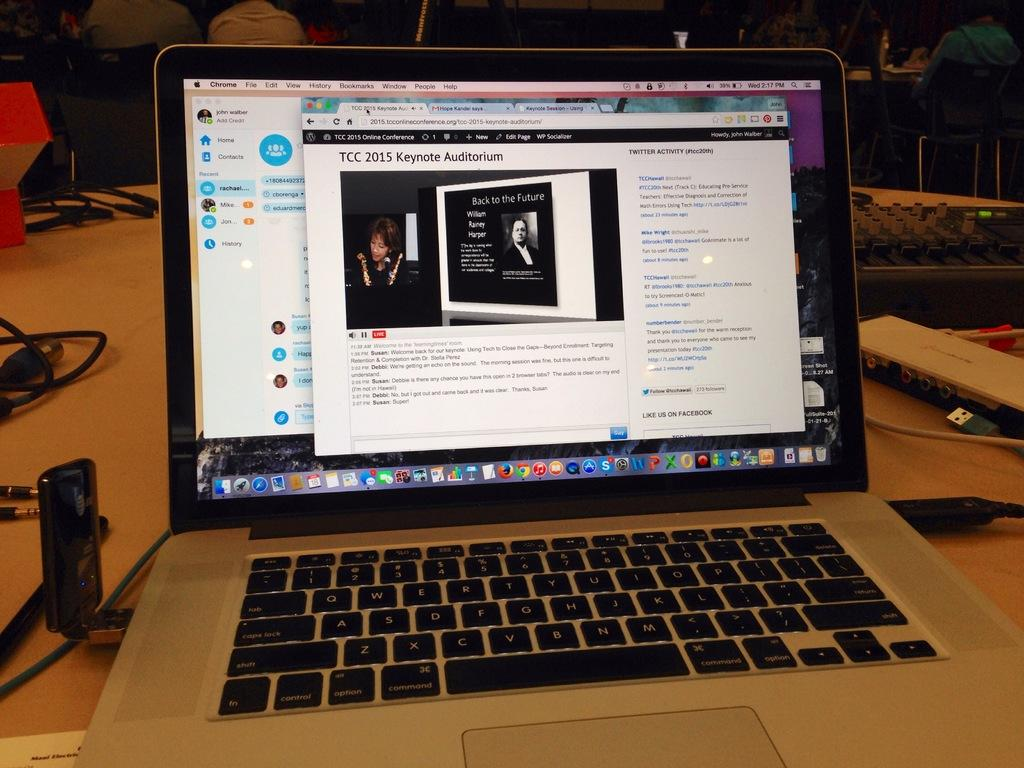<image>
Provide a brief description of the given image. A laptop with an open web page that has TCC 2015 Keynote Auditorium on its screen. 